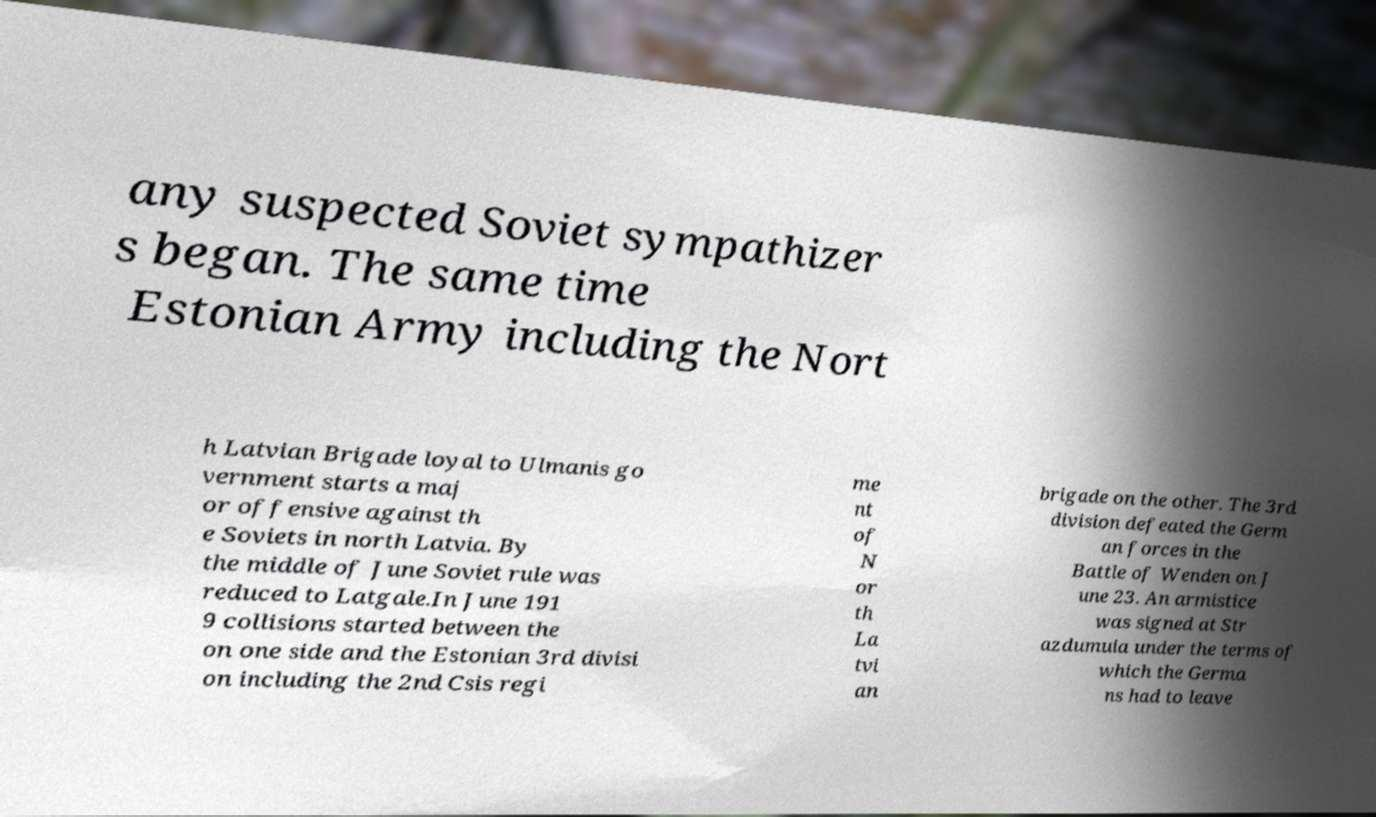Please identify and transcribe the text found in this image. any suspected Soviet sympathizer s began. The same time Estonian Army including the Nort h Latvian Brigade loyal to Ulmanis go vernment starts a maj or offensive against th e Soviets in north Latvia. By the middle of June Soviet rule was reduced to Latgale.In June 191 9 collisions started between the on one side and the Estonian 3rd divisi on including the 2nd Csis regi me nt of N or th La tvi an brigade on the other. The 3rd division defeated the Germ an forces in the Battle of Wenden on J une 23. An armistice was signed at Str azdumuia under the terms of which the Germa ns had to leave 